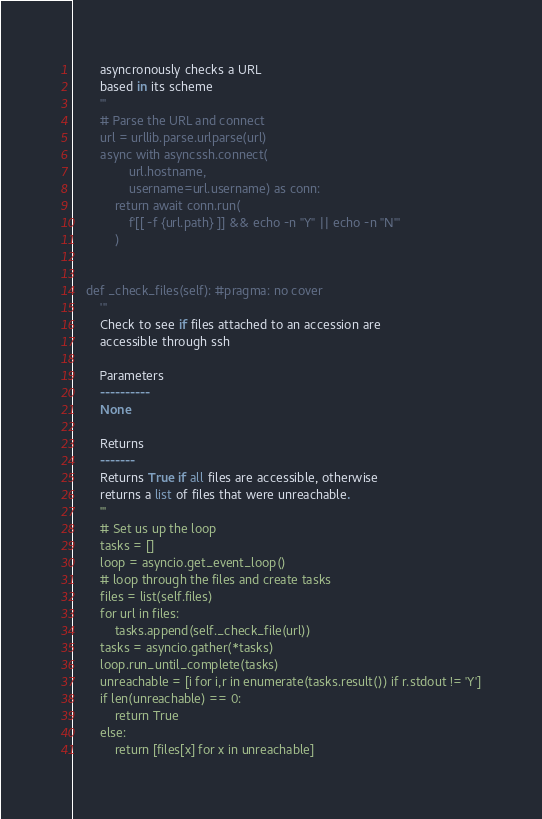Convert code to text. <code><loc_0><loc_0><loc_500><loc_500><_Python_>        asyncronously checks a URL
        based in its scheme
        '''
        # Parse the URL and connect
        url = urllib.parse.urlparse(url)
        async with asyncssh.connect(
                url.hostname,
                username=url.username) as conn:
            return await conn.run(
                f'[[ -f {url.path} ]] && echo -n "Y" || echo -n "N"'
            )


    def _check_files(self): #pragma: no cover
        '''
        Check to see if files attached to an accession are 
        accessible through ssh

        Parameters
        ----------
        None

        Returns
        -------
        Returns True if all files are accessible, otherwise 
        returns a list of files that were unreachable.
        '''
        # Set us up the loop
        tasks = [] 
        loop = asyncio.get_event_loop() 
        # loop through the files and create tasks
        files = list(self.files)
        for url in files:
            tasks.append(self._check_file(url))
        tasks = asyncio.gather(*tasks)
        loop.run_until_complete(tasks)
        unreachable = [i for i,r in enumerate(tasks.result()) if r.stdout != 'Y']
        if len(unreachable) == 0:
            return True
        else:
            return [files[x] for x in unreachable]


</code> 